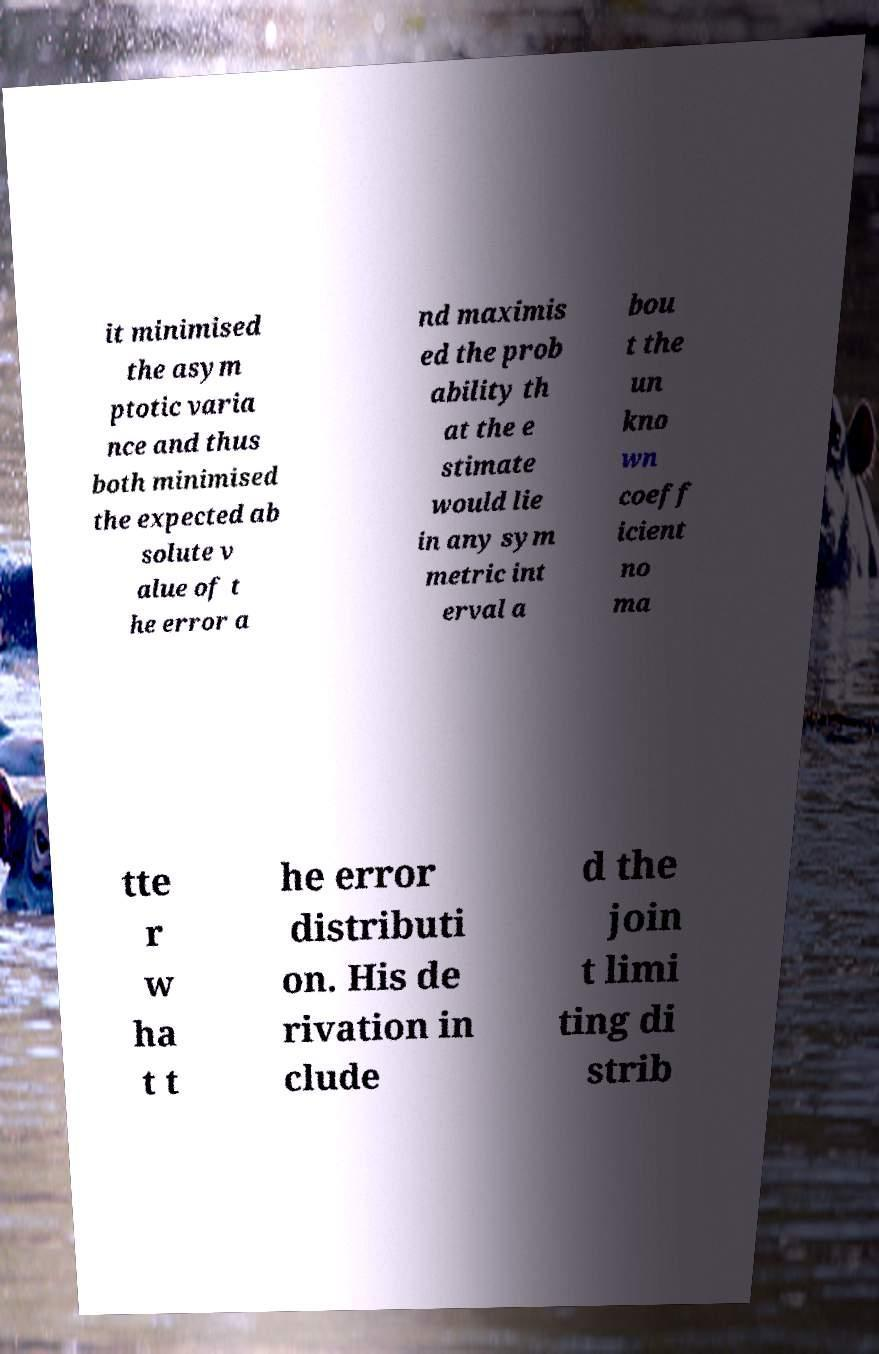Can you accurately transcribe the text from the provided image for me? it minimised the asym ptotic varia nce and thus both minimised the expected ab solute v alue of t he error a nd maximis ed the prob ability th at the e stimate would lie in any sym metric int erval a bou t the un kno wn coeff icient no ma tte r w ha t t he error distributi on. His de rivation in clude d the join t limi ting di strib 